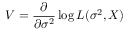<formula> <loc_0><loc_0><loc_500><loc_500>V = { \frac { \partial } { \partial \sigma ^ { 2 } } } \log L ( \sigma ^ { 2 } , X )</formula> 